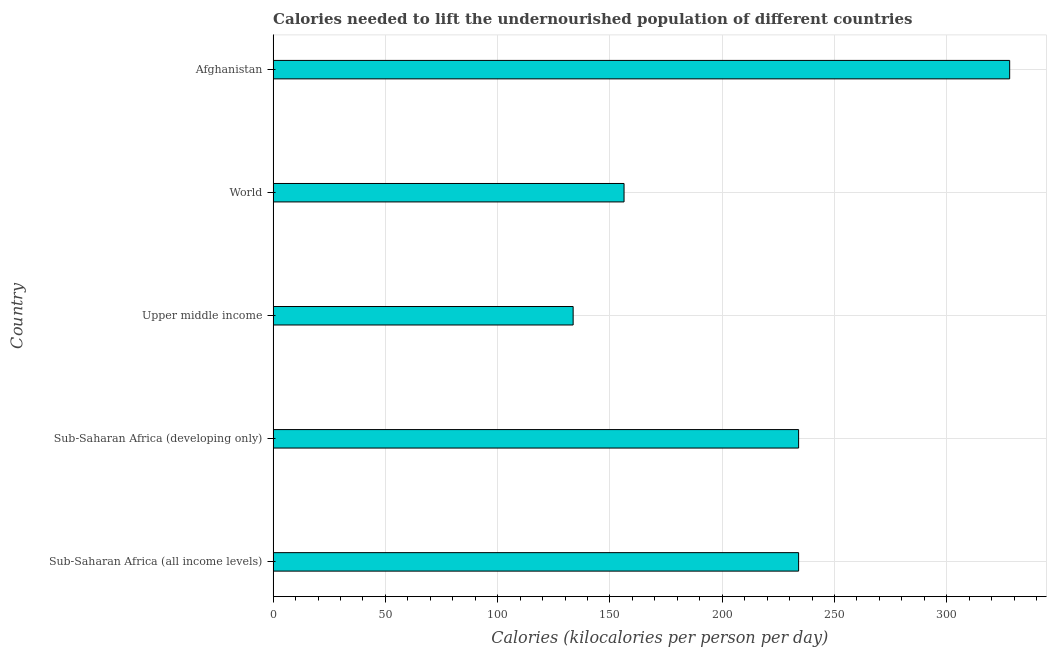What is the title of the graph?
Your response must be concise. Calories needed to lift the undernourished population of different countries. What is the label or title of the X-axis?
Keep it short and to the point. Calories (kilocalories per person per day). What is the depth of food deficit in Afghanistan?
Provide a succinct answer. 328. Across all countries, what is the maximum depth of food deficit?
Make the answer very short. 328. Across all countries, what is the minimum depth of food deficit?
Your response must be concise. 133.61. In which country was the depth of food deficit maximum?
Offer a very short reply. Afghanistan. In which country was the depth of food deficit minimum?
Your response must be concise. Upper middle income. What is the sum of the depth of food deficit?
Keep it short and to the point. 1085.91. What is the difference between the depth of food deficit in Sub-Saharan Africa (all income levels) and Upper middle income?
Your answer should be very brief. 100.41. What is the average depth of food deficit per country?
Give a very brief answer. 217.18. What is the median depth of food deficit?
Provide a succinct answer. 234.01. What is the ratio of the depth of food deficit in Afghanistan to that in World?
Your answer should be very brief. 2.1. Is the difference between the depth of food deficit in Sub-Saharan Africa (all income levels) and World greater than the difference between any two countries?
Keep it short and to the point. No. What is the difference between the highest and the second highest depth of food deficit?
Make the answer very short. 93.98. What is the difference between the highest and the lowest depth of food deficit?
Offer a terse response. 194.39. In how many countries, is the depth of food deficit greater than the average depth of food deficit taken over all countries?
Ensure brevity in your answer.  3. How many bars are there?
Ensure brevity in your answer.  5. How many countries are there in the graph?
Offer a very short reply. 5. What is the Calories (kilocalories per person per day) of Sub-Saharan Africa (all income levels)?
Offer a very short reply. 234.01. What is the Calories (kilocalories per person per day) in Sub-Saharan Africa (developing only)?
Give a very brief answer. 234.01. What is the Calories (kilocalories per person per day) in Upper middle income?
Offer a very short reply. 133.61. What is the Calories (kilocalories per person per day) of World?
Your response must be concise. 156.27. What is the Calories (kilocalories per person per day) of Afghanistan?
Keep it short and to the point. 328. What is the difference between the Calories (kilocalories per person per day) in Sub-Saharan Africa (all income levels) and Upper middle income?
Ensure brevity in your answer.  100.41. What is the difference between the Calories (kilocalories per person per day) in Sub-Saharan Africa (all income levels) and World?
Offer a terse response. 77.74. What is the difference between the Calories (kilocalories per person per day) in Sub-Saharan Africa (all income levels) and Afghanistan?
Make the answer very short. -93.99. What is the difference between the Calories (kilocalories per person per day) in Sub-Saharan Africa (developing only) and Upper middle income?
Ensure brevity in your answer.  100.41. What is the difference between the Calories (kilocalories per person per day) in Sub-Saharan Africa (developing only) and World?
Offer a very short reply. 77.74. What is the difference between the Calories (kilocalories per person per day) in Sub-Saharan Africa (developing only) and Afghanistan?
Provide a succinct answer. -93.99. What is the difference between the Calories (kilocalories per person per day) in Upper middle income and World?
Offer a terse response. -22.67. What is the difference between the Calories (kilocalories per person per day) in Upper middle income and Afghanistan?
Offer a very short reply. -194.39. What is the difference between the Calories (kilocalories per person per day) in World and Afghanistan?
Provide a succinct answer. -171.73. What is the ratio of the Calories (kilocalories per person per day) in Sub-Saharan Africa (all income levels) to that in Upper middle income?
Offer a terse response. 1.75. What is the ratio of the Calories (kilocalories per person per day) in Sub-Saharan Africa (all income levels) to that in World?
Provide a succinct answer. 1.5. What is the ratio of the Calories (kilocalories per person per day) in Sub-Saharan Africa (all income levels) to that in Afghanistan?
Make the answer very short. 0.71. What is the ratio of the Calories (kilocalories per person per day) in Sub-Saharan Africa (developing only) to that in Upper middle income?
Offer a very short reply. 1.75. What is the ratio of the Calories (kilocalories per person per day) in Sub-Saharan Africa (developing only) to that in World?
Your answer should be very brief. 1.5. What is the ratio of the Calories (kilocalories per person per day) in Sub-Saharan Africa (developing only) to that in Afghanistan?
Provide a short and direct response. 0.71. What is the ratio of the Calories (kilocalories per person per day) in Upper middle income to that in World?
Ensure brevity in your answer.  0.85. What is the ratio of the Calories (kilocalories per person per day) in Upper middle income to that in Afghanistan?
Offer a very short reply. 0.41. What is the ratio of the Calories (kilocalories per person per day) in World to that in Afghanistan?
Ensure brevity in your answer.  0.48. 